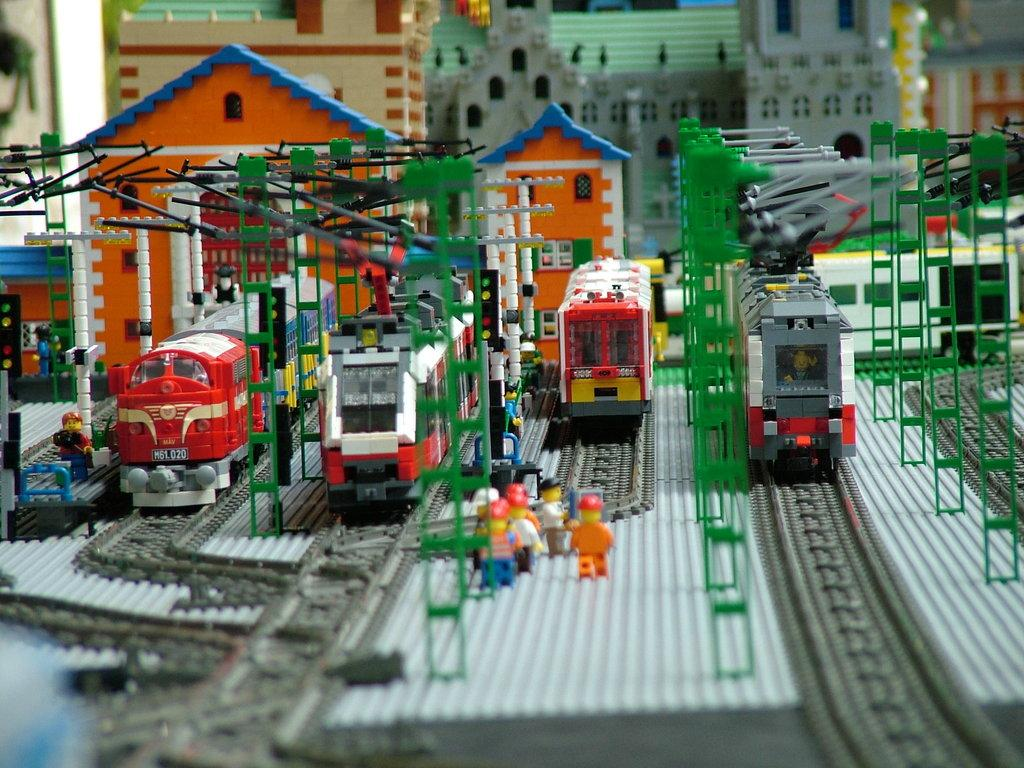What type of toys are present in the image? There are toy buildings, toy trains, and toy persons in the image. Can you describe the toy buildings in the image? The toy buildings are small and resemble real buildings. What are the toy trains doing in the image? The toy trains are either stationary or moving along tracks. How are the toy persons related to the toy buildings and trains? The toy persons may be interacting with the toy buildings and trains, or they may be placed near them. Is there a fire hydrant visible in the image? No, there is no fire hydrant present in the image. Can you tell me what time of day it is in the image? The image does not provide any information about the time of day. 